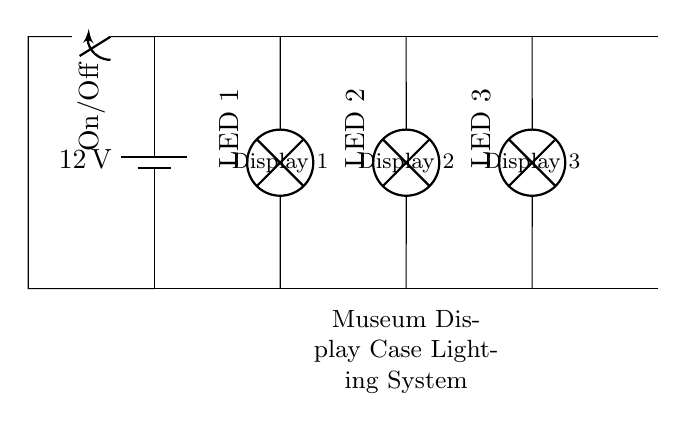What is the voltage source in this circuit? The voltage source shown in the circuit diagram is a battery, specifically labeled as 12 volts. This is indicated next to the battery symbol in the drawing, designating it as the power supply for the entire circuit.
Answer: 12 volts How many lamps are connected in parallel? The circuit diagram illustrates three lamps connected in parallel to the power source. Each lamp is represented on its own branch, which is a characteristic feature of a parallel circuit.
Answer: Three lamps What type of circuit is shown here? The circuit diagram depicts a parallel circuit, where multiple components (in this case, lamps) are connected across the same two points of the circuit. This allows for each lamp to operate independently.
Answer: Parallel circuit What happens if one lamp fails? If one lamp fails in a parallel circuit, the remaining lamps continue to operate normally. This characteristic is due to the independent branches in a parallel configuration, meaning that each lamp has its own path for current flow.
Answer: Remaining lamps operate What component allows you to turn the display on or off? A switch is included in the circuit diagram, labeled as an On/Off switch. This component controls the flow of electricity throughout the entire circuit and can open or close the circuit path when operated.
Answer: Switch What does the labeling "LED 1", "LED 2", and "LED 3" indicate? The labels "LED 1", "LED 2", and "LED 3" identify each of the lamps in the circuit. These labels indicate the different displays that the lighting system serves, allowing for organization and clarity in understanding which lamp corresponds to which display.
Answer: Display identification 